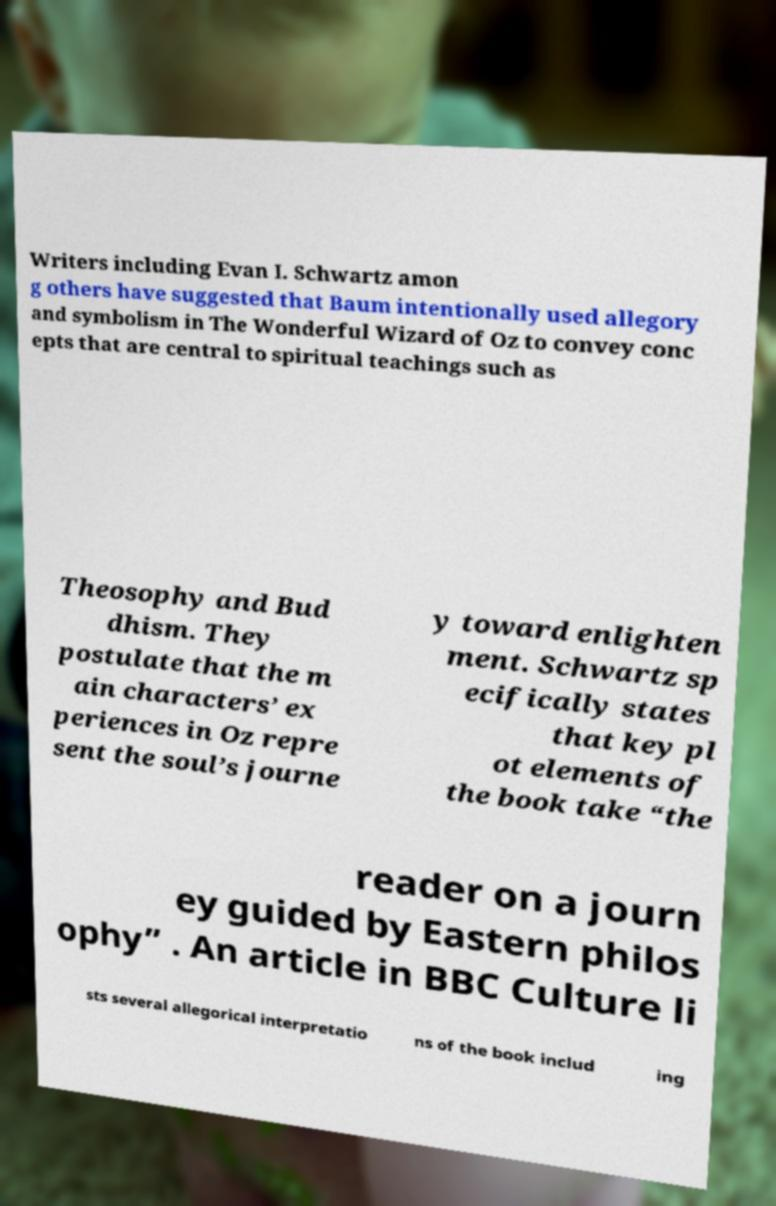Could you assist in decoding the text presented in this image and type it out clearly? Writers including Evan I. Schwartz amon g others have suggested that Baum intentionally used allegory and symbolism in The Wonderful Wizard of Oz to convey conc epts that are central to spiritual teachings such as Theosophy and Bud dhism. They postulate that the m ain characters’ ex periences in Oz repre sent the soul’s journe y toward enlighten ment. Schwartz sp ecifically states that key pl ot elements of the book take “the reader on a journ ey guided by Eastern philos ophy” . An article in BBC Culture li sts several allegorical interpretatio ns of the book includ ing 